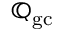<formula> <loc_0><loc_0><loc_500><loc_500>\mathbb { Q } _ { g c }</formula> 